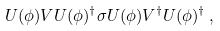Convert formula to latex. <formula><loc_0><loc_0><loc_500><loc_500>U ( \phi ) V U ( \phi ) ^ { \dag } \sigma U ( \phi ) V ^ { \dag } U ( \phi ) ^ { \dag } \, ,</formula> 